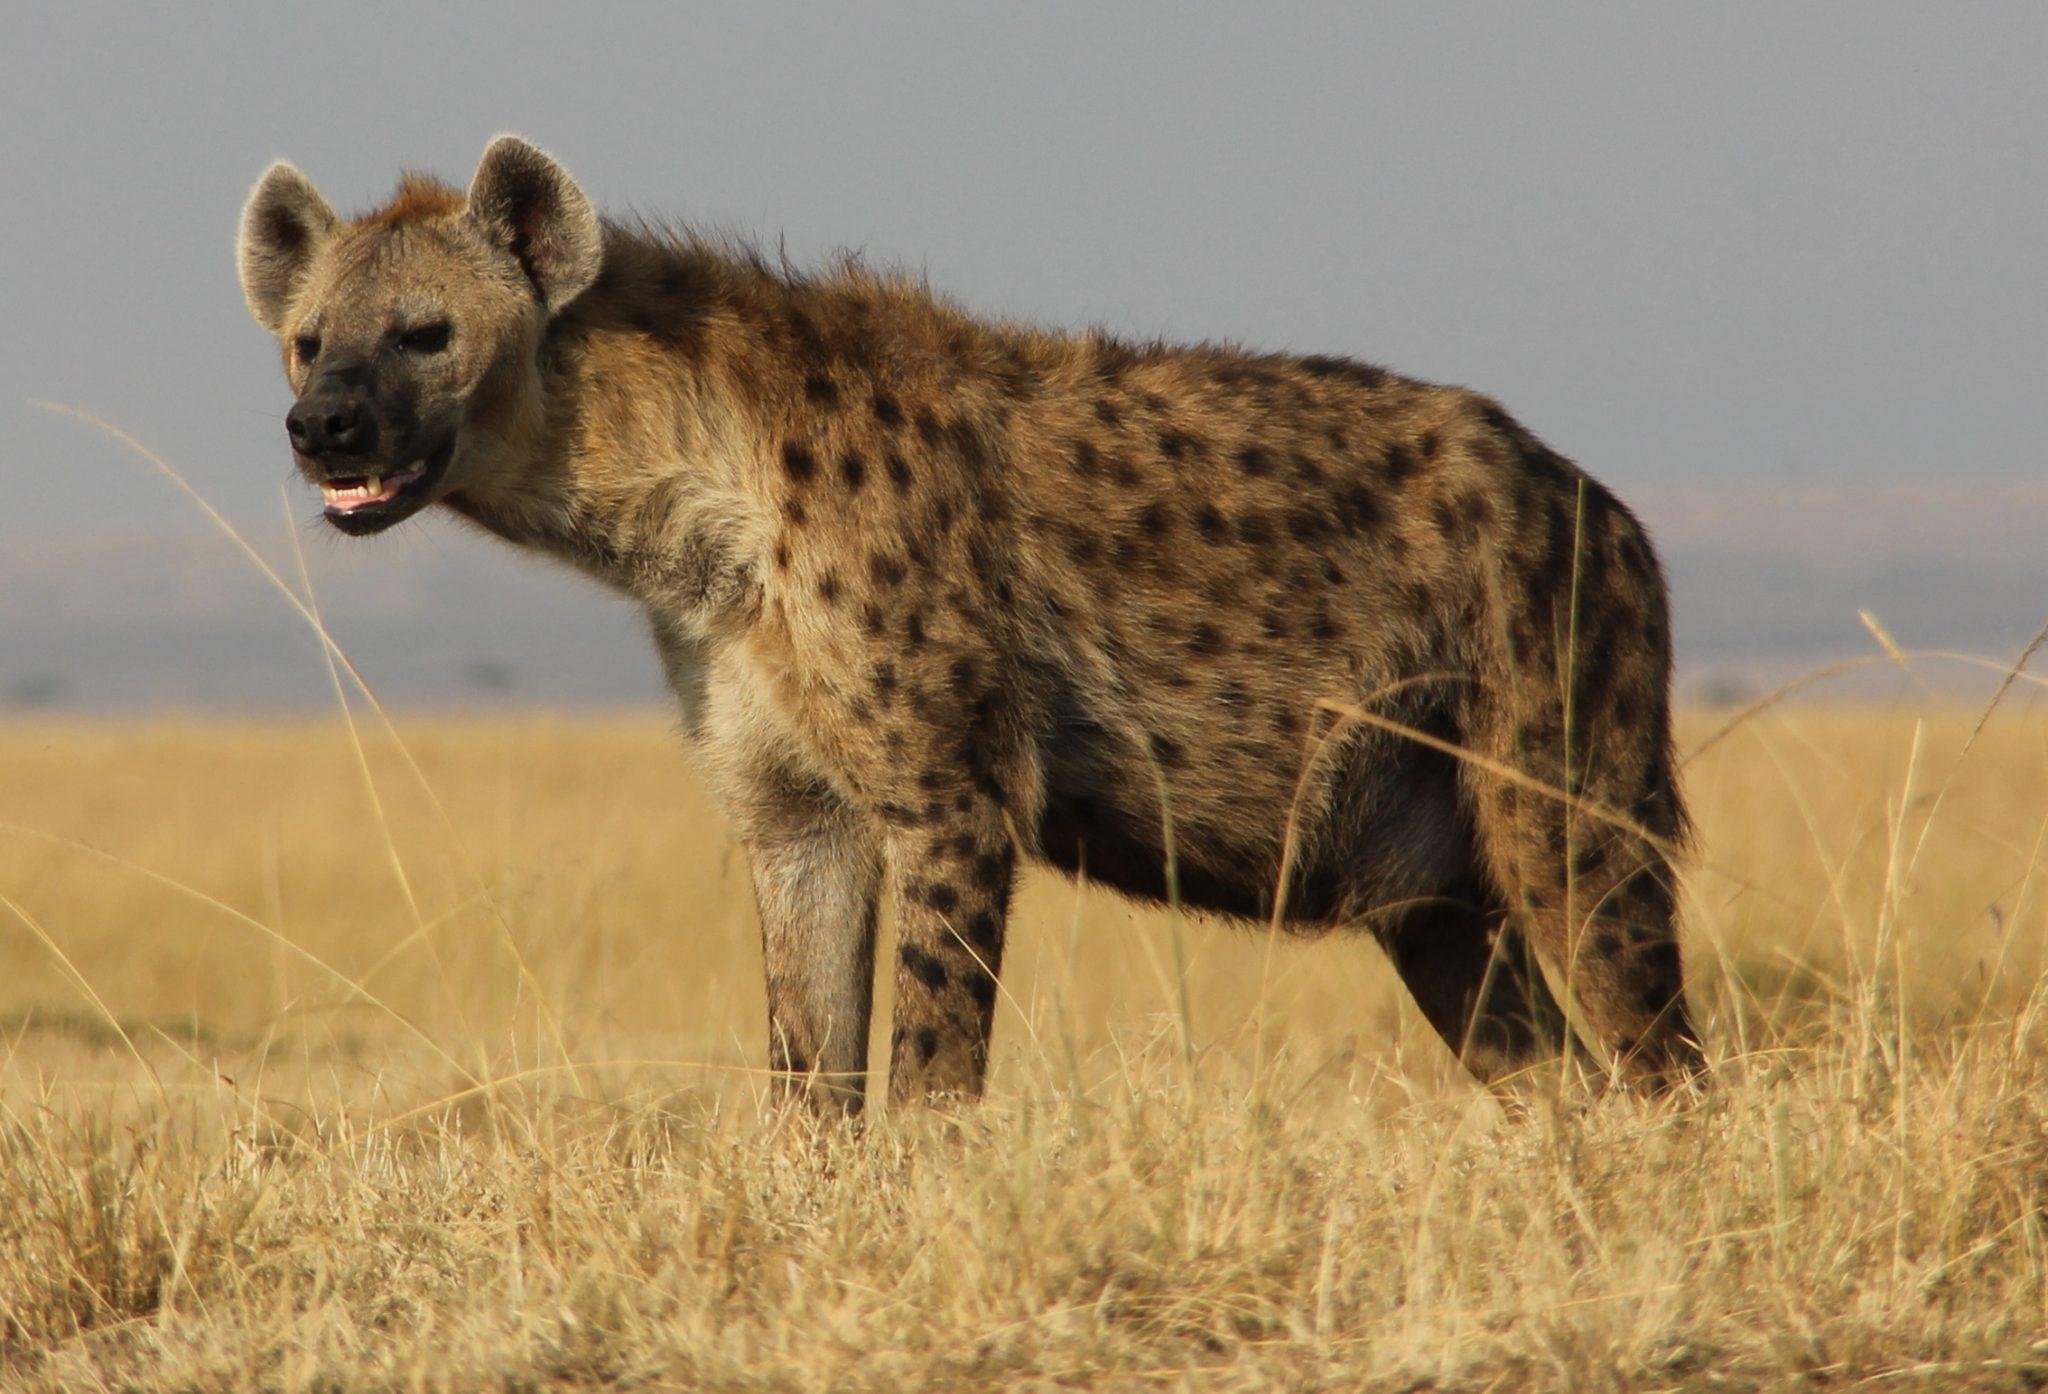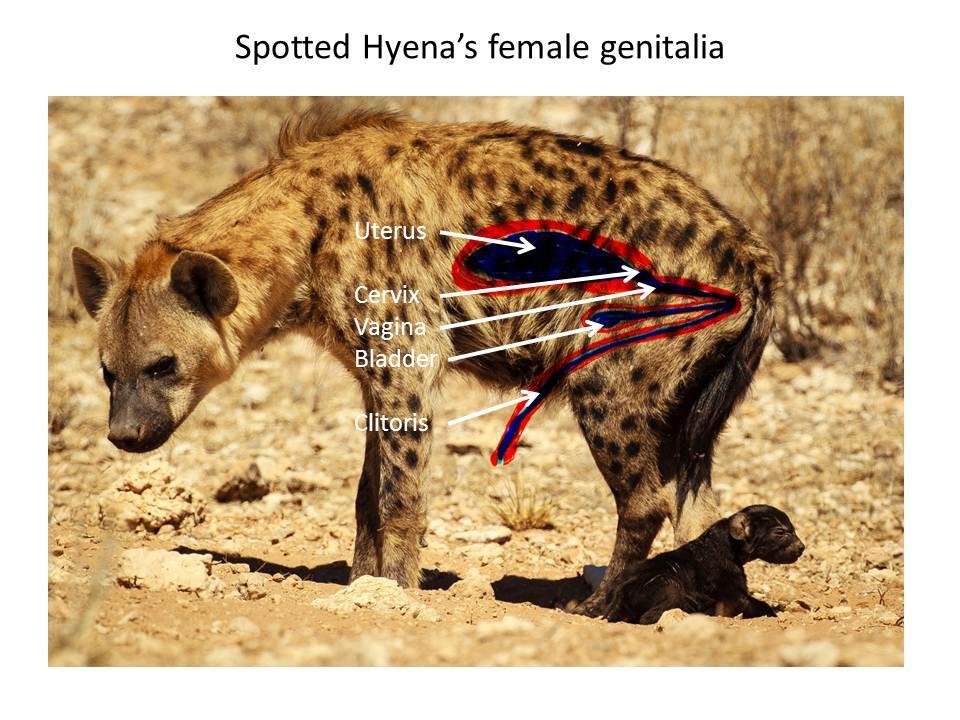The first image is the image on the left, the second image is the image on the right. For the images shown, is this caption "There are exactly two animals in the image on the left." true? Answer yes or no. No. 